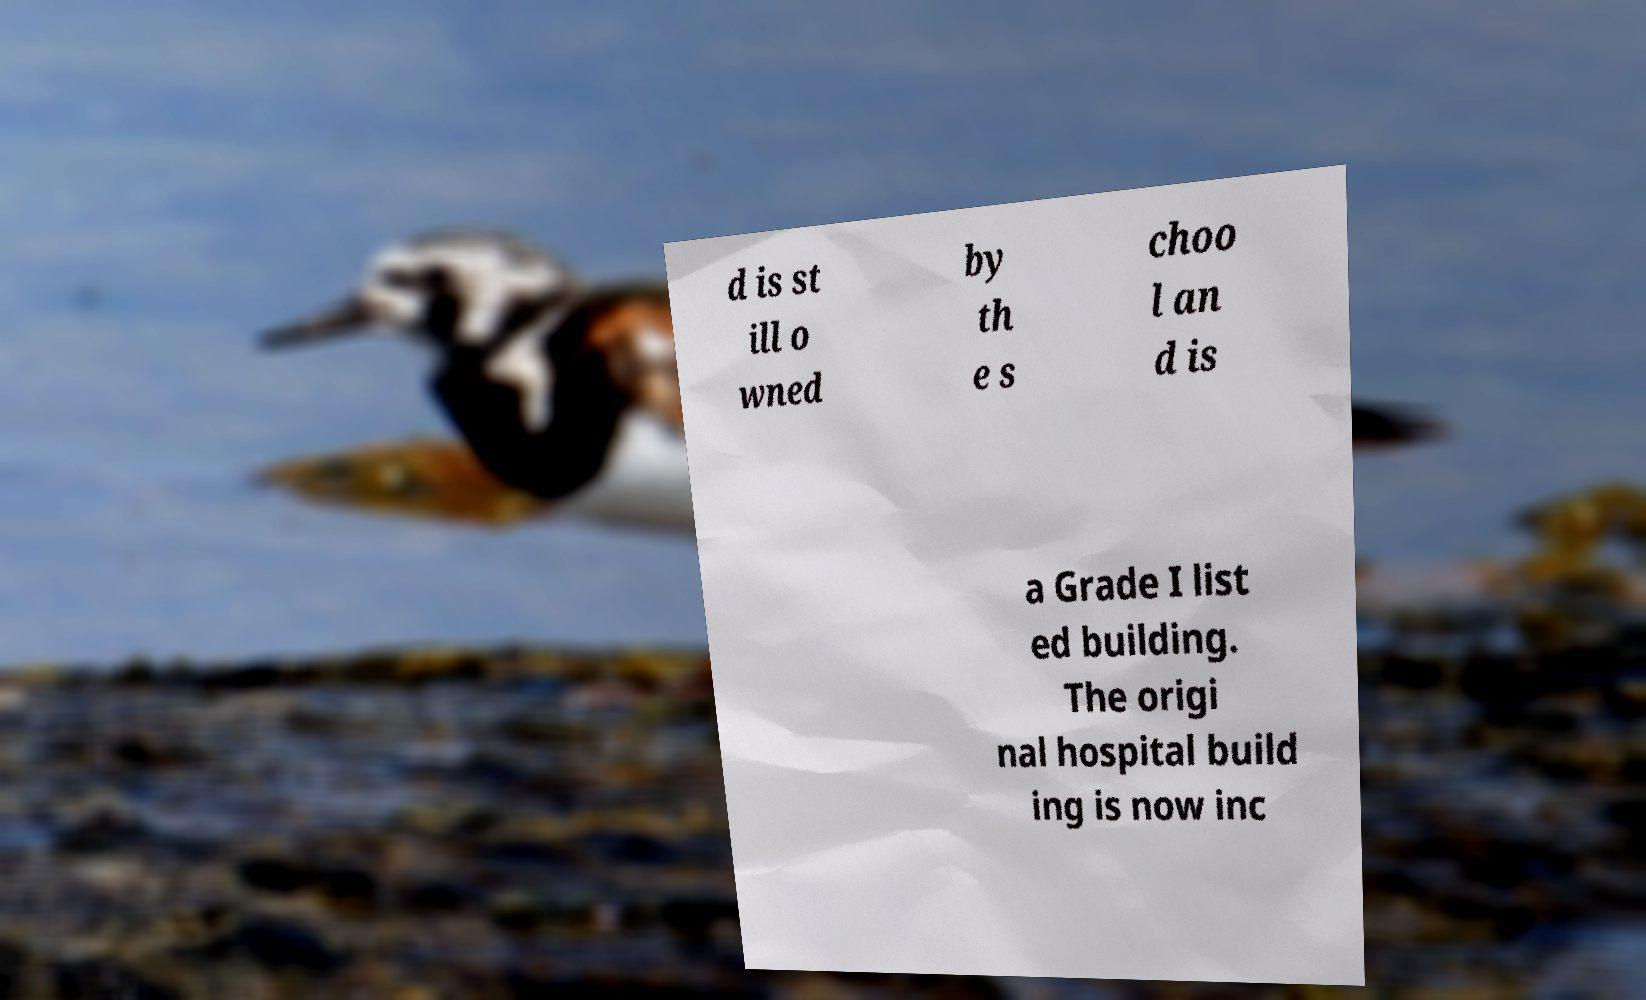I need the written content from this picture converted into text. Can you do that? d is st ill o wned by th e s choo l an d is a Grade I list ed building. The origi nal hospital build ing is now inc 